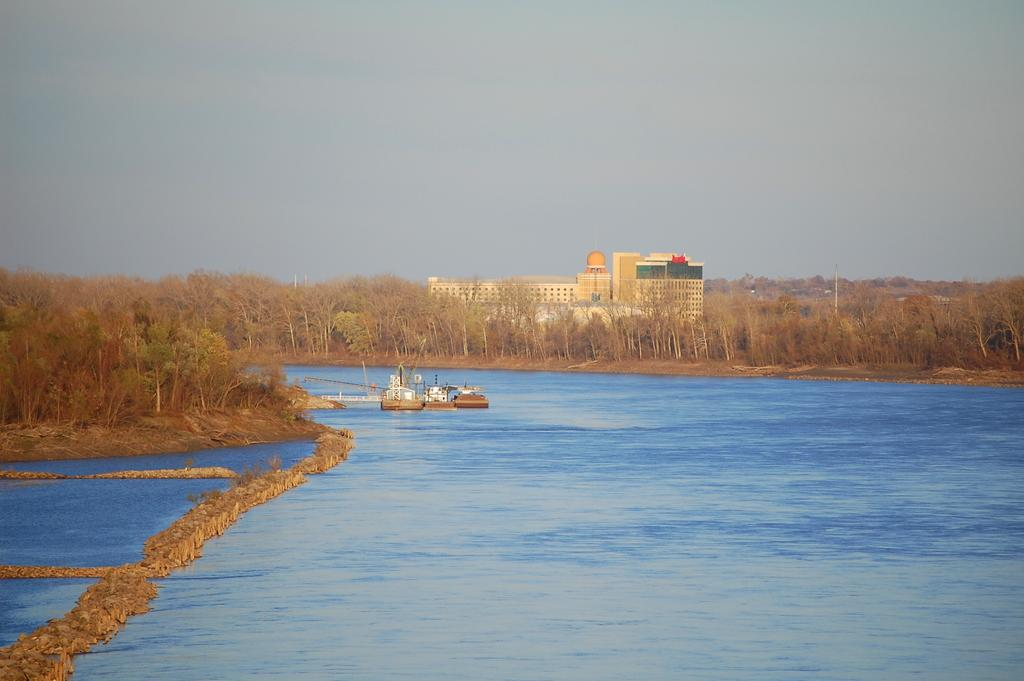What type of structure is visible in the image? There is a building with windows in the image. What can be seen on the ground in the image? The ground is visible in the image, and there is grass present. What type of vegetation is visible in the image? Plants and trees are visible in the image. What is present in the water in the image? Boats are present in the water. What else can be seen in the image? There is a pole in the image, and the sky is visible. Where is the shelf located in the image? There is no shelf present in the image. What type of pig can be seen interacting with the boats in the image? There is no pig present in the image; only boats are visible in the water. 